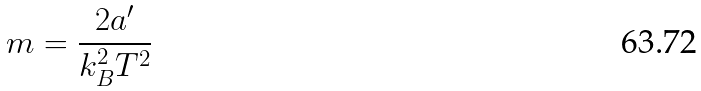Convert formula to latex. <formula><loc_0><loc_0><loc_500><loc_500>m = \frac { 2 a ^ { \prime } } { k _ { B } ^ { 2 } T ^ { 2 } }</formula> 